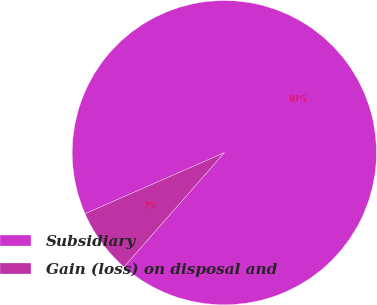Convert chart. <chart><loc_0><loc_0><loc_500><loc_500><pie_chart><fcel>Subsidiary<fcel>Gain (loss) on disposal and<nl><fcel>93.05%<fcel>6.95%<nl></chart> 